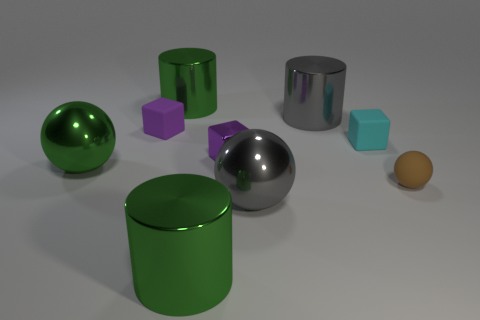Subtract all green balls. How many balls are left? 2 Add 1 gray shiny balls. How many objects exist? 10 Subtract all green spheres. How many spheres are left? 2 Subtract all blocks. How many objects are left? 6 Subtract 3 balls. How many balls are left? 0 Subtract all purple blocks. Subtract all cyan cylinders. How many blocks are left? 1 Subtract all cyan blocks. How many green balls are left? 1 Subtract all tiny metal cubes. Subtract all big metal objects. How many objects are left? 3 Add 2 green metal objects. How many green metal objects are left? 5 Add 6 matte objects. How many matte objects exist? 9 